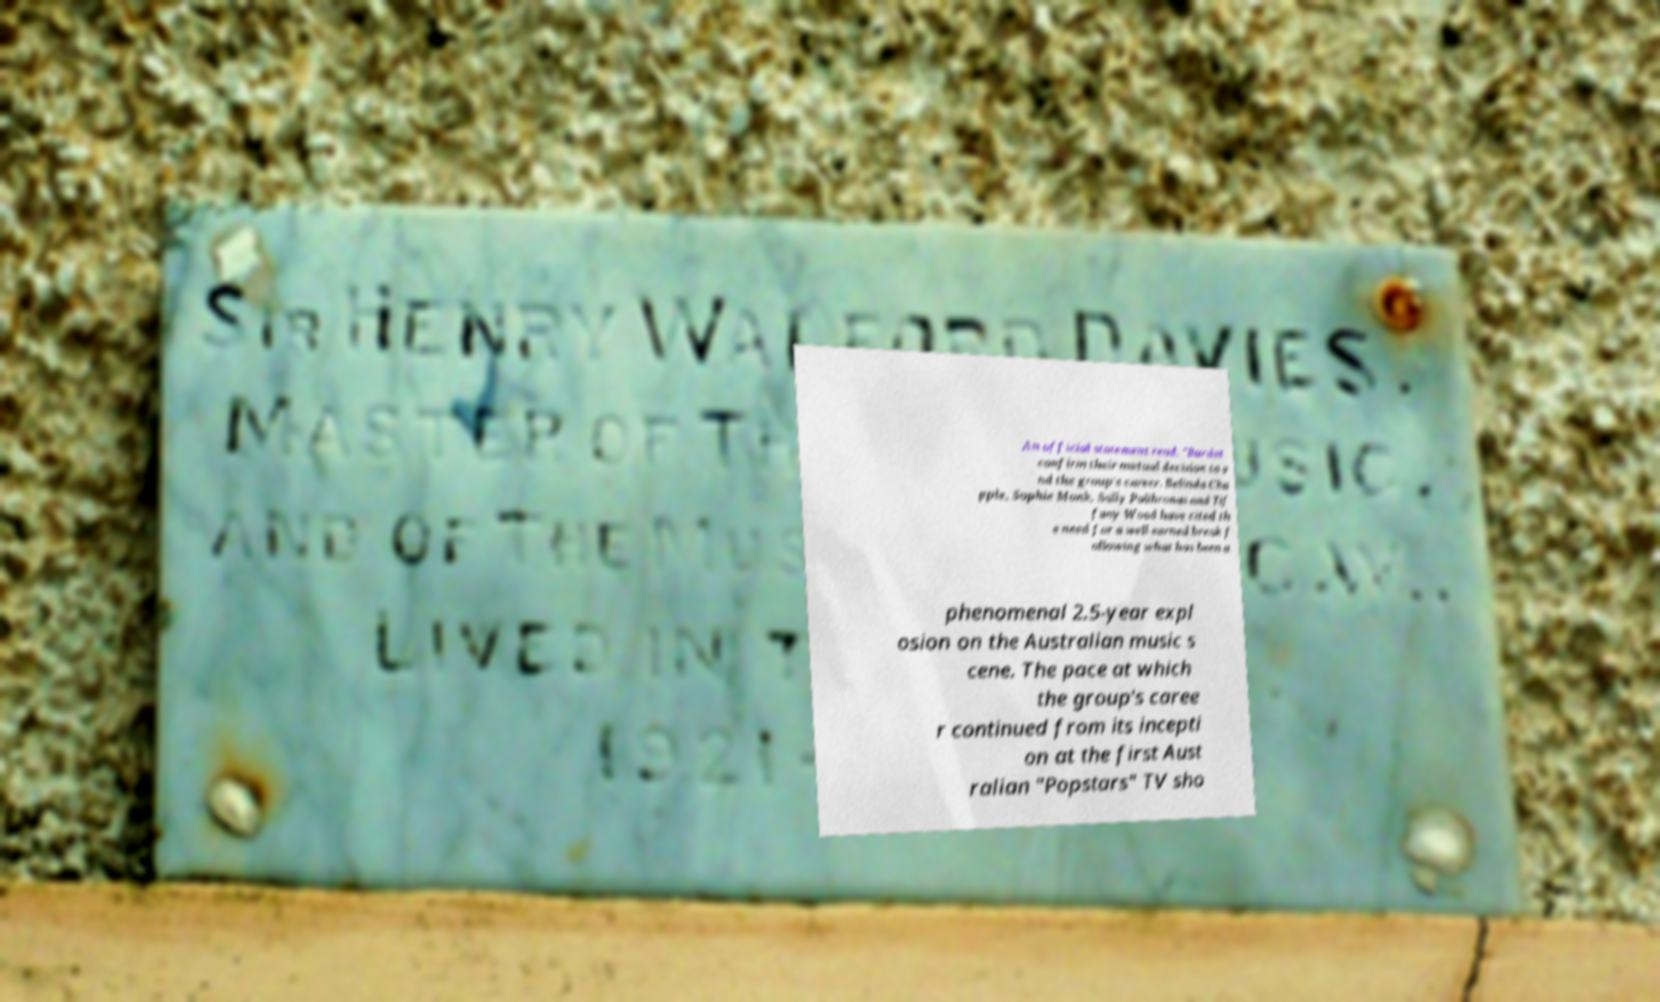Please read and relay the text visible in this image. What does it say? An official statement read: "Bardot confirm their mutual decision to e nd the group's career. Belinda Cha pple, Sophie Monk, Sally Polihronas and Tif fany Wood have cited th e need for a well earned break f ollowing what has been a phenomenal 2.5-year expl osion on the Australian music s cene. The pace at which the group's caree r continued from its incepti on at the first Aust ralian "Popstars" TV sho 